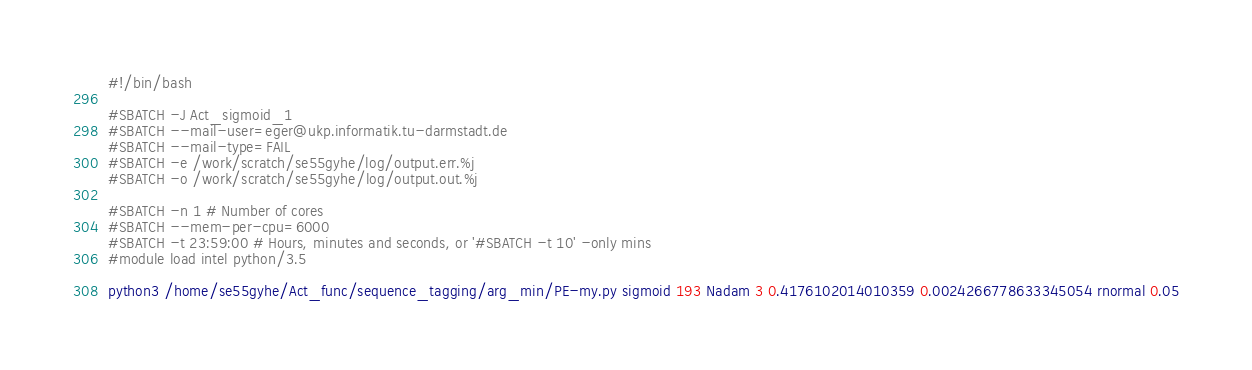<code> <loc_0><loc_0><loc_500><loc_500><_Bash_>#!/bin/bash
 
#SBATCH -J Act_sigmoid_1
#SBATCH --mail-user=eger@ukp.informatik.tu-darmstadt.de
#SBATCH --mail-type=FAIL
#SBATCH -e /work/scratch/se55gyhe/log/output.err.%j
#SBATCH -o /work/scratch/se55gyhe/log/output.out.%j

#SBATCH -n 1 # Number of cores
#SBATCH --mem-per-cpu=6000
#SBATCH -t 23:59:00 # Hours, minutes and seconds, or '#SBATCH -t 10' -only mins
#module load intel python/3.5

python3 /home/se55gyhe/Act_func/sequence_tagging/arg_min/PE-my.py sigmoid 193 Nadam 3 0.4176102014010359 0.0024266778633345054 rnormal 0.05

</code> 